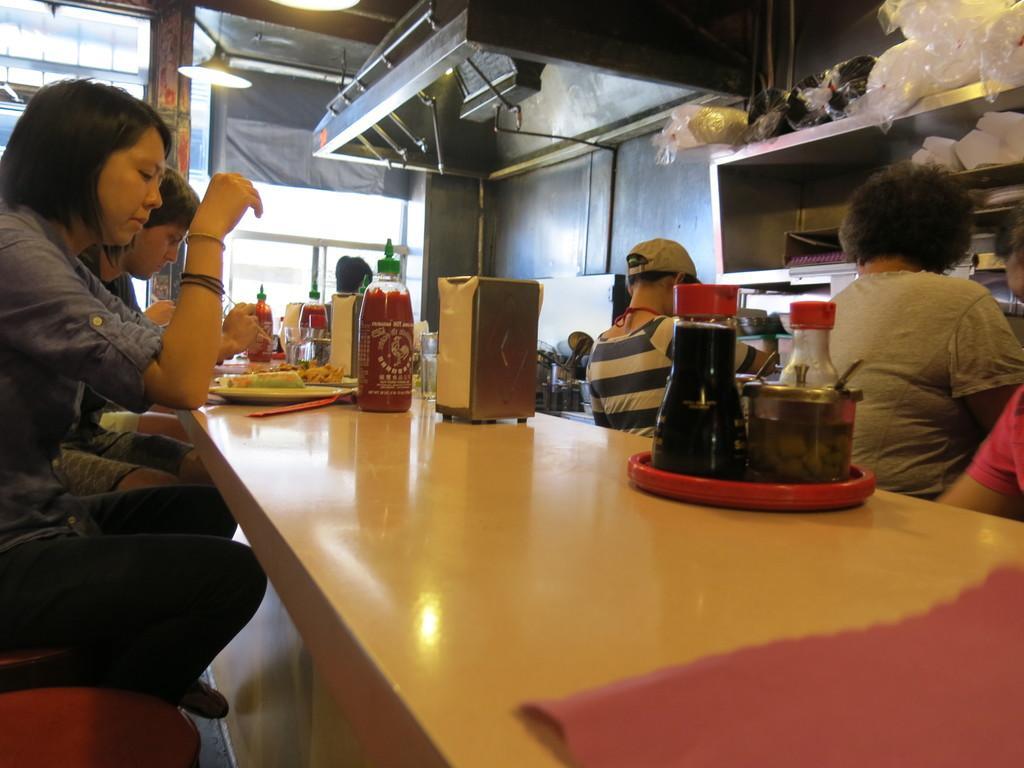Describe this image in one or two sentences. As we can see in the image there is a light, few people sitting on chairs and there is a table. On table there is a plate, bottles and boxes. 